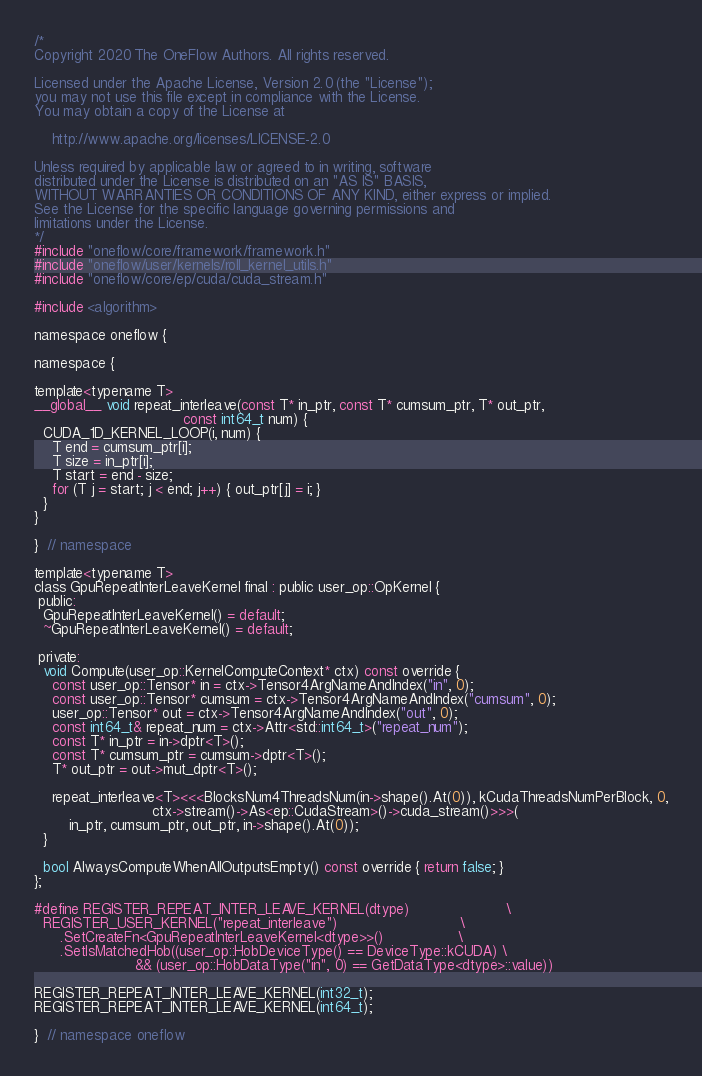<code> <loc_0><loc_0><loc_500><loc_500><_Cuda_>/*
Copyright 2020 The OneFlow Authors. All rights reserved.

Licensed under the Apache License, Version 2.0 (the "License");
you may not use this file except in compliance with the License.
You may obtain a copy of the License at

    http://www.apache.org/licenses/LICENSE-2.0

Unless required by applicable law or agreed to in writing, software
distributed under the License is distributed on an "AS IS" BASIS,
WITHOUT WARRANTIES OR CONDITIONS OF ANY KIND, either express or implied.
See the License for the specific language governing permissions and
limitations under the License.
*/
#include "oneflow/core/framework/framework.h"
#include "oneflow/user/kernels/roll_kernel_utils.h"
#include "oneflow/core/ep/cuda/cuda_stream.h"

#include <algorithm>

namespace oneflow {

namespace {

template<typename T>
__global__ void repeat_interleave(const T* in_ptr, const T* cumsum_ptr, T* out_ptr,
                                  const int64_t num) {
  CUDA_1D_KERNEL_LOOP(i, num) {
    T end = cumsum_ptr[i];
    T size = in_ptr[i];
    T start = end - size;
    for (T j = start; j < end; j++) { out_ptr[j] = i; }
  }
}

}  // namespace

template<typename T>
class GpuRepeatInterLeaveKernel final : public user_op::OpKernel {
 public:
  GpuRepeatInterLeaveKernel() = default;
  ~GpuRepeatInterLeaveKernel() = default;

 private:
  void Compute(user_op::KernelComputeContext* ctx) const override {
    const user_op::Tensor* in = ctx->Tensor4ArgNameAndIndex("in", 0);
    const user_op::Tensor* cumsum = ctx->Tensor4ArgNameAndIndex("cumsum", 0);
    user_op::Tensor* out = ctx->Tensor4ArgNameAndIndex("out", 0);
    const int64_t& repeat_num = ctx->Attr<std::int64_t>("repeat_num");
    const T* in_ptr = in->dptr<T>();
    const T* cumsum_ptr = cumsum->dptr<T>();
    T* out_ptr = out->mut_dptr<T>();

    repeat_interleave<T><<<BlocksNum4ThreadsNum(in->shape().At(0)), kCudaThreadsNumPerBlock, 0,
                           ctx->stream()->As<ep::CudaStream>()->cuda_stream()>>>(
        in_ptr, cumsum_ptr, out_ptr, in->shape().At(0));
  }

  bool AlwaysComputeWhenAllOutputsEmpty() const override { return false; }
};

#define REGISTER_REPEAT_INTER_LEAVE_KERNEL(dtype)                      \
  REGISTER_USER_KERNEL("repeat_interleave")                            \
      .SetCreateFn<GpuRepeatInterLeaveKernel<dtype>>()                 \
      .SetIsMatchedHob((user_op::HobDeviceType() == DeviceType::kCUDA) \
                       && (user_op::HobDataType("in", 0) == GetDataType<dtype>::value))

REGISTER_REPEAT_INTER_LEAVE_KERNEL(int32_t);
REGISTER_REPEAT_INTER_LEAVE_KERNEL(int64_t);

}  // namespace oneflow
</code> 